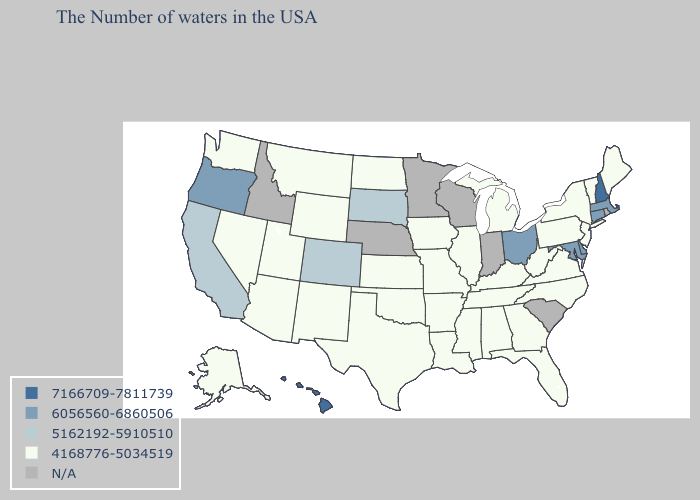Among the states that border New Mexico , does Colorado have the lowest value?
Quick response, please. No. Name the states that have a value in the range 5162192-5910510?
Short answer required. South Dakota, Colorado, California. Which states have the lowest value in the South?
Give a very brief answer. Virginia, North Carolina, West Virginia, Florida, Georgia, Kentucky, Alabama, Tennessee, Mississippi, Louisiana, Arkansas, Oklahoma, Texas. Is the legend a continuous bar?
Keep it brief. No. What is the value of Mississippi?
Quick response, please. 4168776-5034519. How many symbols are there in the legend?
Quick response, please. 5. What is the value of South Carolina?
Answer briefly. N/A. What is the lowest value in the West?
Answer briefly. 4168776-5034519. Does the first symbol in the legend represent the smallest category?
Write a very short answer. No. What is the value of Texas?
Be succinct. 4168776-5034519. Name the states that have a value in the range 6056560-6860506?
Write a very short answer. Massachusetts, Connecticut, Delaware, Maryland, Ohio, Oregon. Among the states that border Kentucky , which have the lowest value?
Quick response, please. Virginia, West Virginia, Tennessee, Illinois, Missouri. Name the states that have a value in the range 6056560-6860506?
Be succinct. Massachusetts, Connecticut, Delaware, Maryland, Ohio, Oregon. What is the value of North Carolina?
Short answer required. 4168776-5034519. 